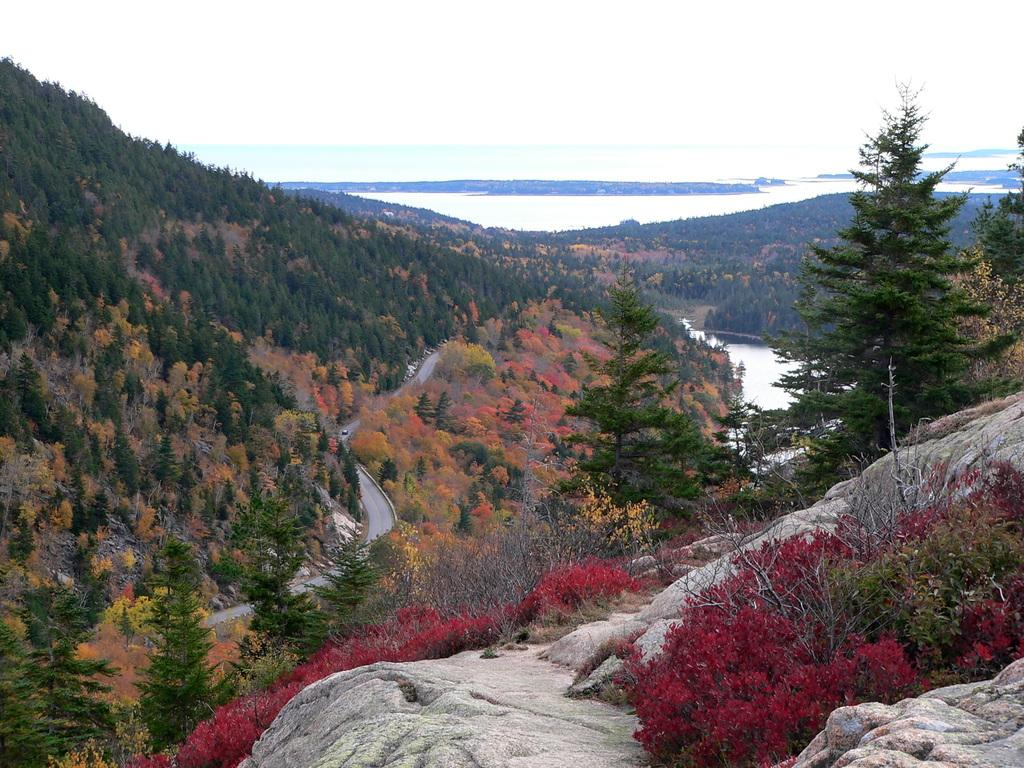What can be seen on either side of the road in the foreground of the image? There are trees on either side of the road in the foreground of the image. What elements are present in the right bottom corner of the image? There are plants, stone, and trees in the right bottom corner of the image. What is visible at the top of the image? Water and the sky are visible at the top of the image. Where is the lunchroom located in the image? There is no lunchroom present in the image. What type of game is being played in the image? There is no game being played in the image. 